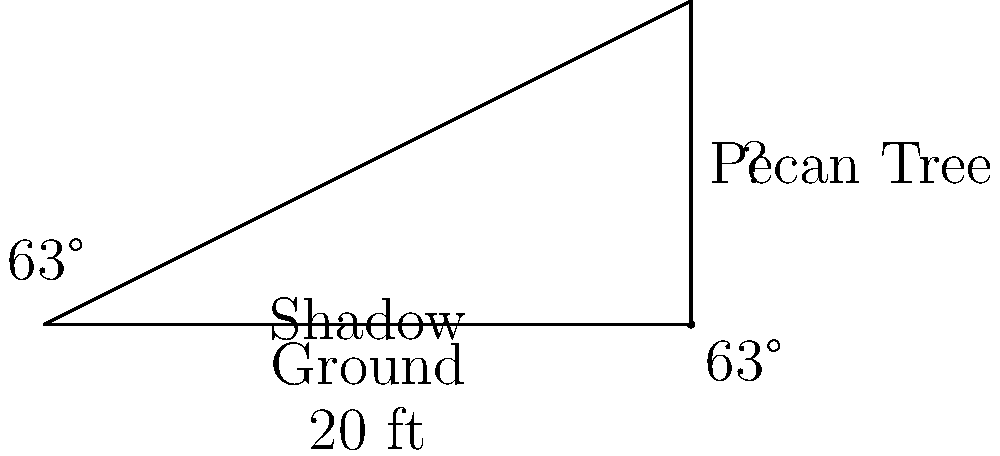A pecan farmer in Mansura, Louisiana wants to determine the height of one of his tallest pecan trees. On a sunny day, he measures the tree's shadow to be 20 feet long. Using a clinometer, he finds that the angle of elevation from the end of the shadow to the top of the tree is 63°. What is the height of the pecan tree, rounded to the nearest foot? Let's solve this step-by-step using trigonometry:

1) We can model this situation as a right triangle, where:
   - The shadow length is the base of the triangle
   - The tree height is the opposite side
   - The angle of elevation is the angle between the base and the hypotenuse

2) We know:
   - The adjacent side (shadow length) = 20 feet
   - The angle of elevation = 63°

3) We need to find the opposite side (tree height). The trigonometric ratio that relates the opposite side to the adjacent side is the tangent.

4) The formula is:
   $\tan(\theta) = \frac{\text{opposite}}{\text{adjacent}}$

5) Substituting our known values:
   $\tan(63°) = \frac{\text{tree height}}{20}$

6) Solving for tree height:
   $\text{tree height} = 20 \times \tan(63°)$

7) Using a calculator:
   $\text{tree height} = 20 \times 1.9626 = 39.252$ feet

8) Rounding to the nearest foot:
   $\text{tree height} \approx 39$ feet
Answer: 39 feet 